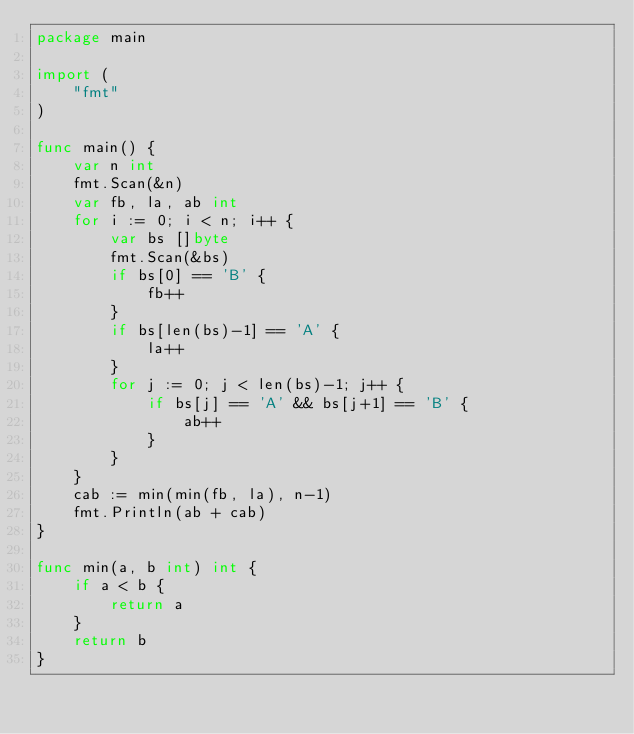Convert code to text. <code><loc_0><loc_0><loc_500><loc_500><_Go_>package main

import (
    "fmt"
)

func main() {
    var n int
    fmt.Scan(&n)
    var fb, la, ab int
    for i := 0; i < n; i++ {
        var bs []byte
        fmt.Scan(&bs)
        if bs[0] == 'B' {
            fb++
        }
        if bs[len(bs)-1] == 'A' {
            la++
        }
        for j := 0; j < len(bs)-1; j++ {
            if bs[j] == 'A' && bs[j+1] == 'B' {
                ab++
            }
        }
    }
    cab := min(min(fb, la), n-1)
    fmt.Println(ab + cab)
}

func min(a, b int) int {
    if a < b {
        return a
    }
    return b
}
</code> 